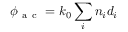Convert formula to latex. <formula><loc_0><loc_0><loc_500><loc_500>\phi _ { a c } = k _ { 0 } \sum _ { i } n _ { i } d _ { i }</formula> 